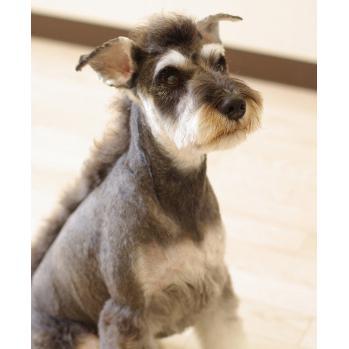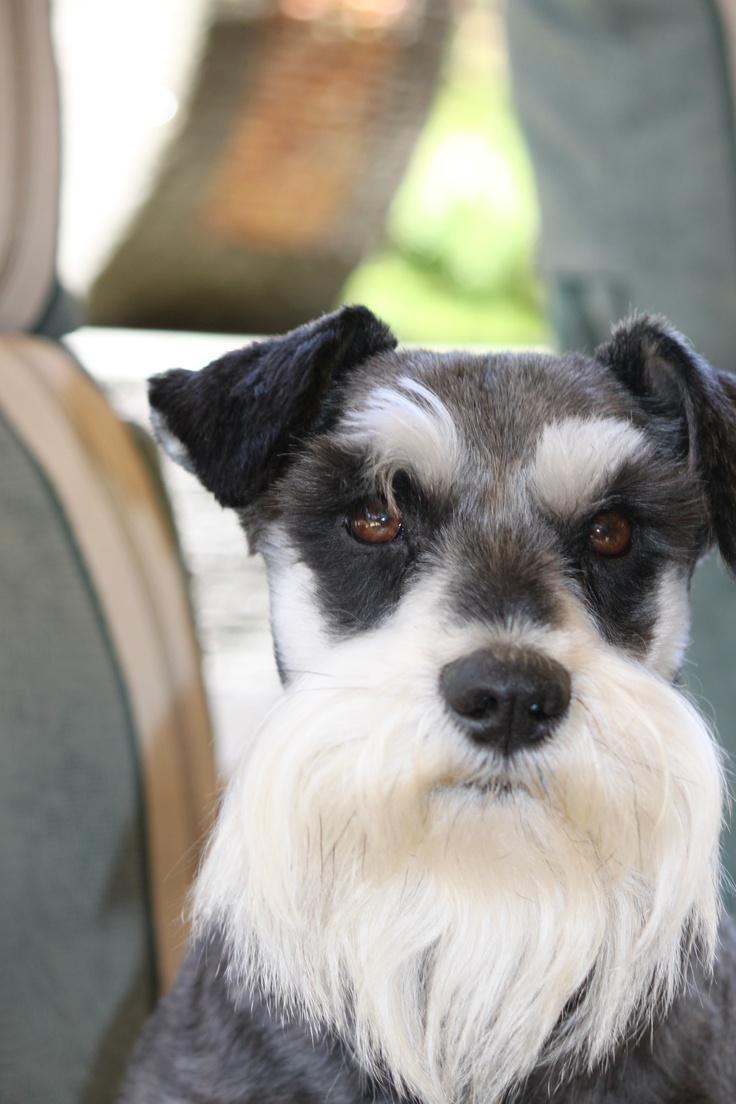The first image is the image on the left, the second image is the image on the right. Given the left and right images, does the statement "In one of the images a dog can be seen wearing a collar." hold true? Answer yes or no. No. 